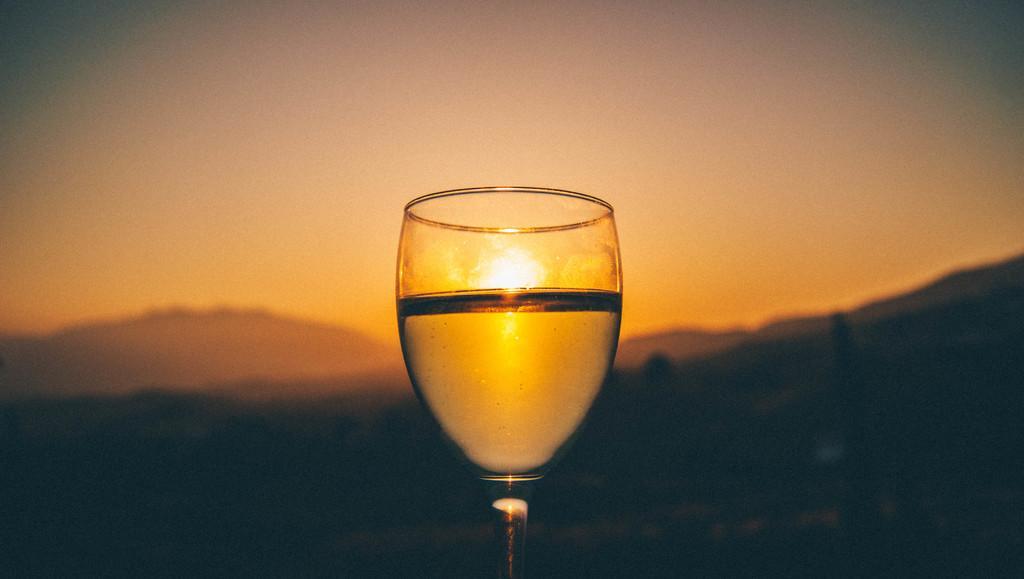Please provide a concise description of this image. In this image there is a glass, in the background there is a sun rise and in bottom it is dark. 